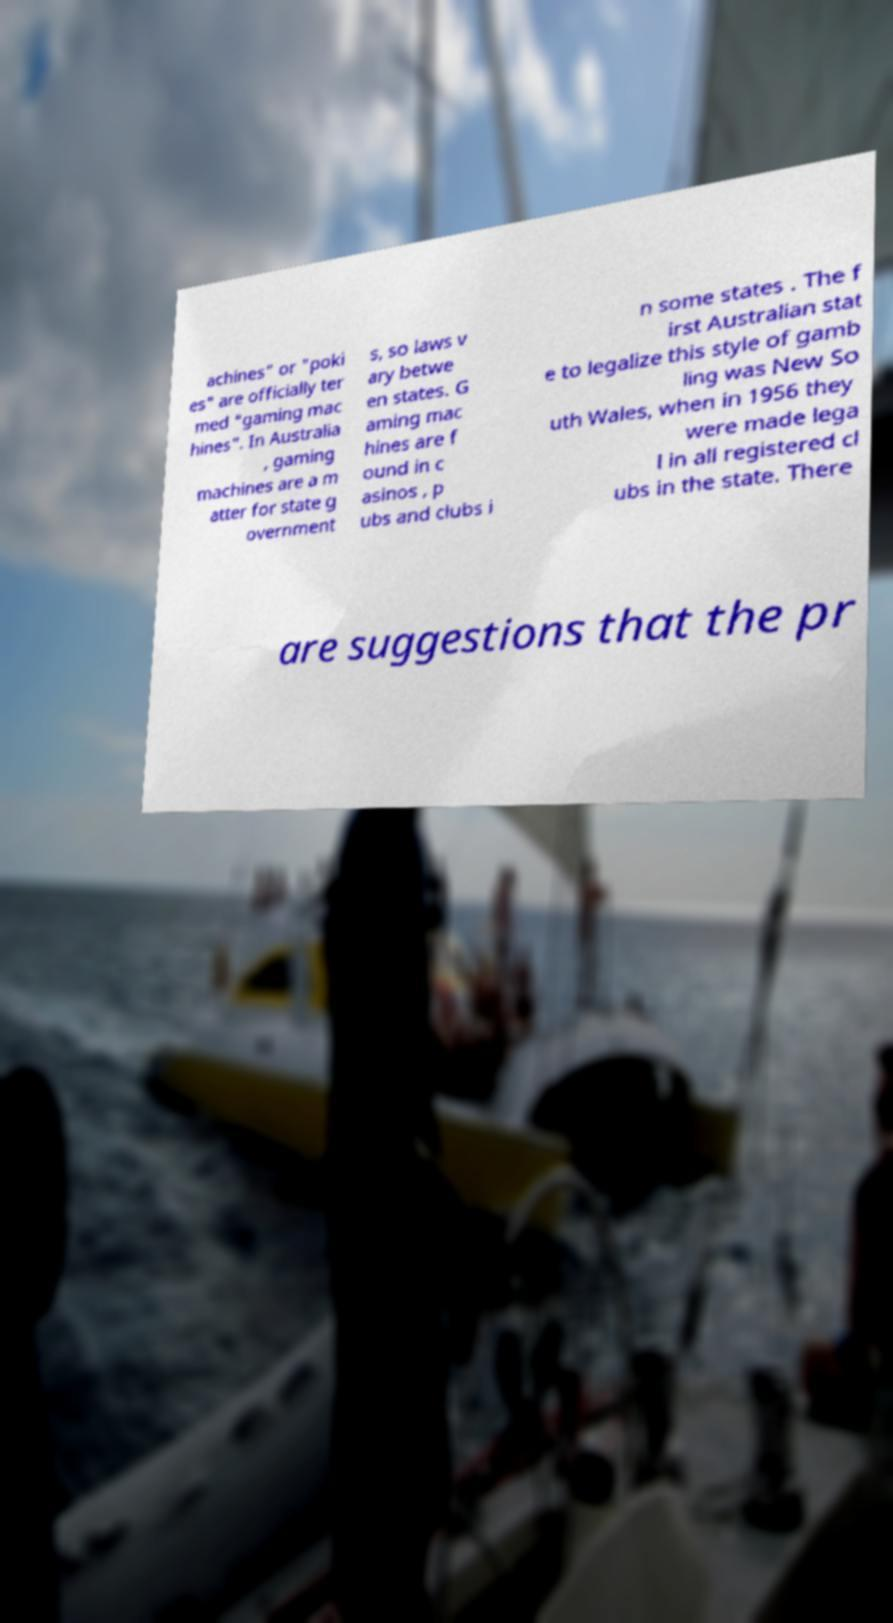What messages or text are displayed in this image? I need them in a readable, typed format. achines" or "poki es" are officially ter med "gaming mac hines". In Australia , gaming machines are a m atter for state g overnment s, so laws v ary betwe en states. G aming mac hines are f ound in c asinos , p ubs and clubs i n some states . The f irst Australian stat e to legalize this style of gamb ling was New So uth Wales, when in 1956 they were made lega l in all registered cl ubs in the state. There are suggestions that the pr 